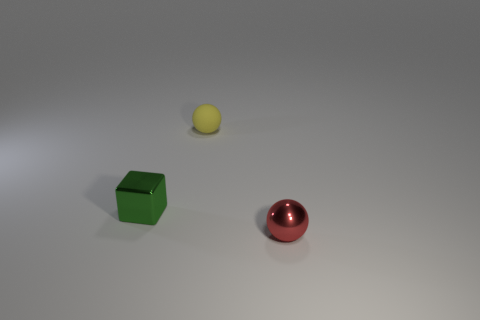Is there any other thing that has the same material as the small yellow ball?
Provide a short and direct response. No. How many small blue metallic spheres are there?
Provide a short and direct response. 0. What material is the small thing that is in front of the tiny thing that is on the left side of the small yellow sphere?
Keep it short and to the point. Metal. There is a metallic thing on the right side of the ball to the left of the small ball that is in front of the metal block; what color is it?
Offer a very short reply. Red. What number of green cubes have the same size as the red thing?
Your answer should be very brief. 1. Is the number of tiny red balls in front of the green shiny block greater than the number of red metallic balls that are to the left of the red ball?
Keep it short and to the point. Yes. The sphere left of the sphere in front of the green metal block is what color?
Ensure brevity in your answer.  Yellow. Does the red thing have the same material as the green block?
Ensure brevity in your answer.  Yes. Is there a tiny metallic thing of the same shape as the tiny yellow matte object?
Offer a terse response. Yes. There is a thing in front of the green shiny cube; does it have the same size as the thing that is behind the small green metal thing?
Your answer should be compact. Yes. 